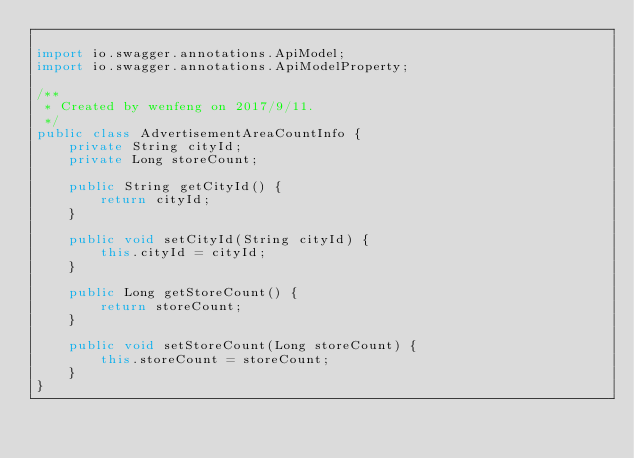Convert code to text. <code><loc_0><loc_0><loc_500><loc_500><_Java_>
import io.swagger.annotations.ApiModel;
import io.swagger.annotations.ApiModelProperty;

/**
 * Created by wenfeng on 2017/9/11.
 */
public class AdvertisementAreaCountInfo {
    private String cityId;
    private Long storeCount;

    public String getCityId() {
        return cityId;
    }

    public void setCityId(String cityId) {
        this.cityId = cityId;
    }

    public Long getStoreCount() {
        return storeCount;
    }

    public void setStoreCount(Long storeCount) {
        this.storeCount = storeCount;
    }
}
</code> 